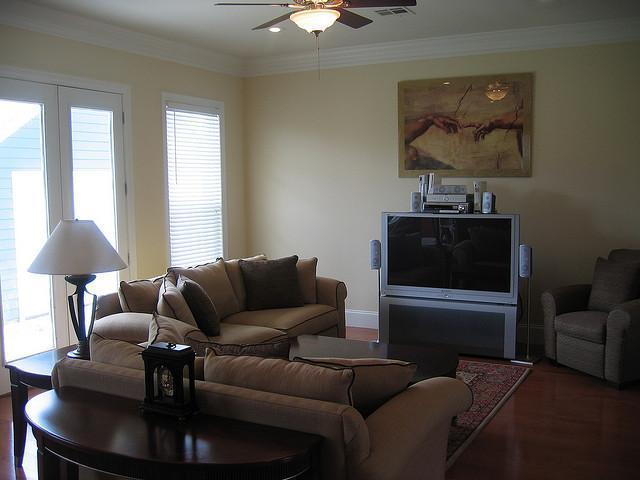How many couches are there?
Give a very brief answer. 2. How many sofas are pictured?
Give a very brief answer. 2. 